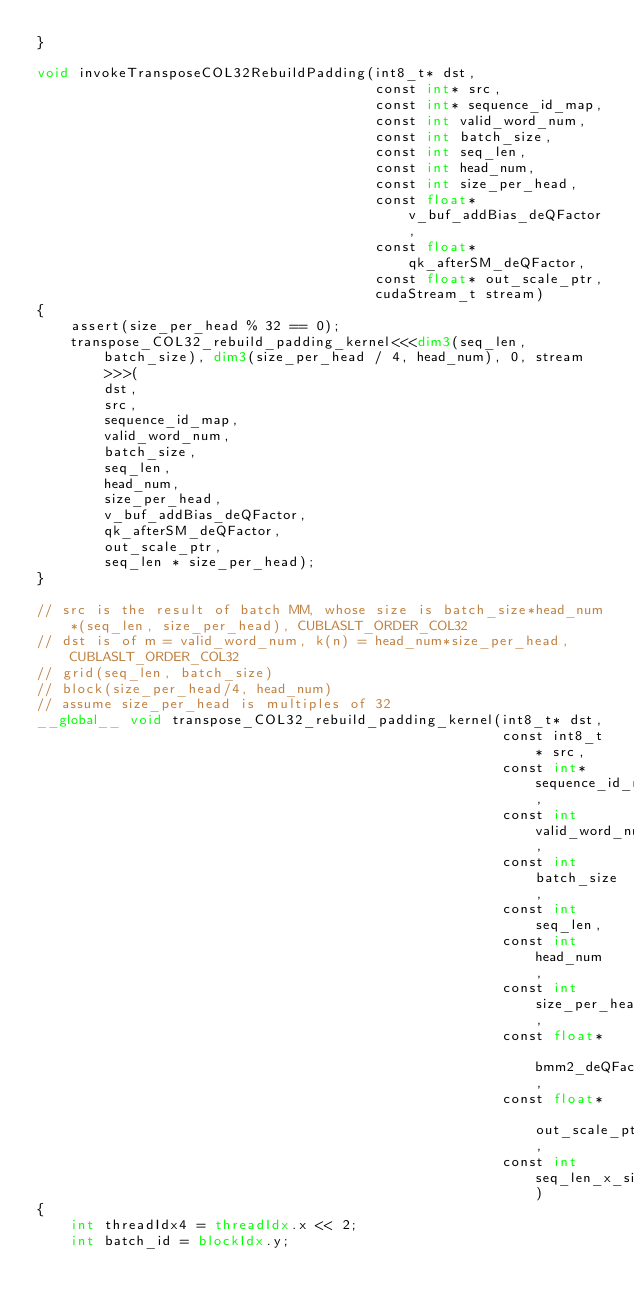<code> <loc_0><loc_0><loc_500><loc_500><_Cuda_>}

void invokeTransposeCOL32RebuildPadding(int8_t* dst,
                                        const int* src,
                                        const int* sequence_id_map,
                                        const int valid_word_num,
                                        const int batch_size,
                                        const int seq_len,
                                        const int head_num,
                                        const int size_per_head,
                                        const float* v_buf_addBias_deQFactor,
                                        const float* qk_afterSM_deQFactor,
                                        const float* out_scale_ptr,
                                        cudaStream_t stream)
{
    assert(size_per_head % 32 == 0);
    transpose_COL32_rebuild_padding_kernel<<<dim3(seq_len, batch_size), dim3(size_per_head / 4, head_num), 0, stream>>>(
        dst,
        src,
        sequence_id_map,
        valid_word_num,
        batch_size,
        seq_len,
        head_num,
        size_per_head,
        v_buf_addBias_deQFactor,
        qk_afterSM_deQFactor,
        out_scale_ptr,
        seq_len * size_per_head);
}

// src is the result of batch MM, whose size is batch_size*head_num*(seq_len, size_per_head), CUBLASLT_ORDER_COL32
// dst is of m = valid_word_num, k(n) = head_num*size_per_head, CUBLASLT_ORDER_COL32
// grid(seq_len, batch_size)
// block(size_per_head/4, head_num)
// assume size_per_head is multiples of 32
__global__ void transpose_COL32_rebuild_padding_kernel(int8_t* dst,
                                                       const int8_t* src,
                                                       const int* sequence_id_map,
                                                       const int valid_word_num,
                                                       const int batch_size,
                                                       const int seq_len,
                                                       const int head_num,
                                                       const int size_per_head,
                                                       const float* bmm2_deQFactor,
                                                       const float* out_scale_ptr,
                                                       const int seq_len_x_size_per_head)
{
    int threadIdx4 = threadIdx.x << 2;
    int batch_id = blockIdx.y;</code> 